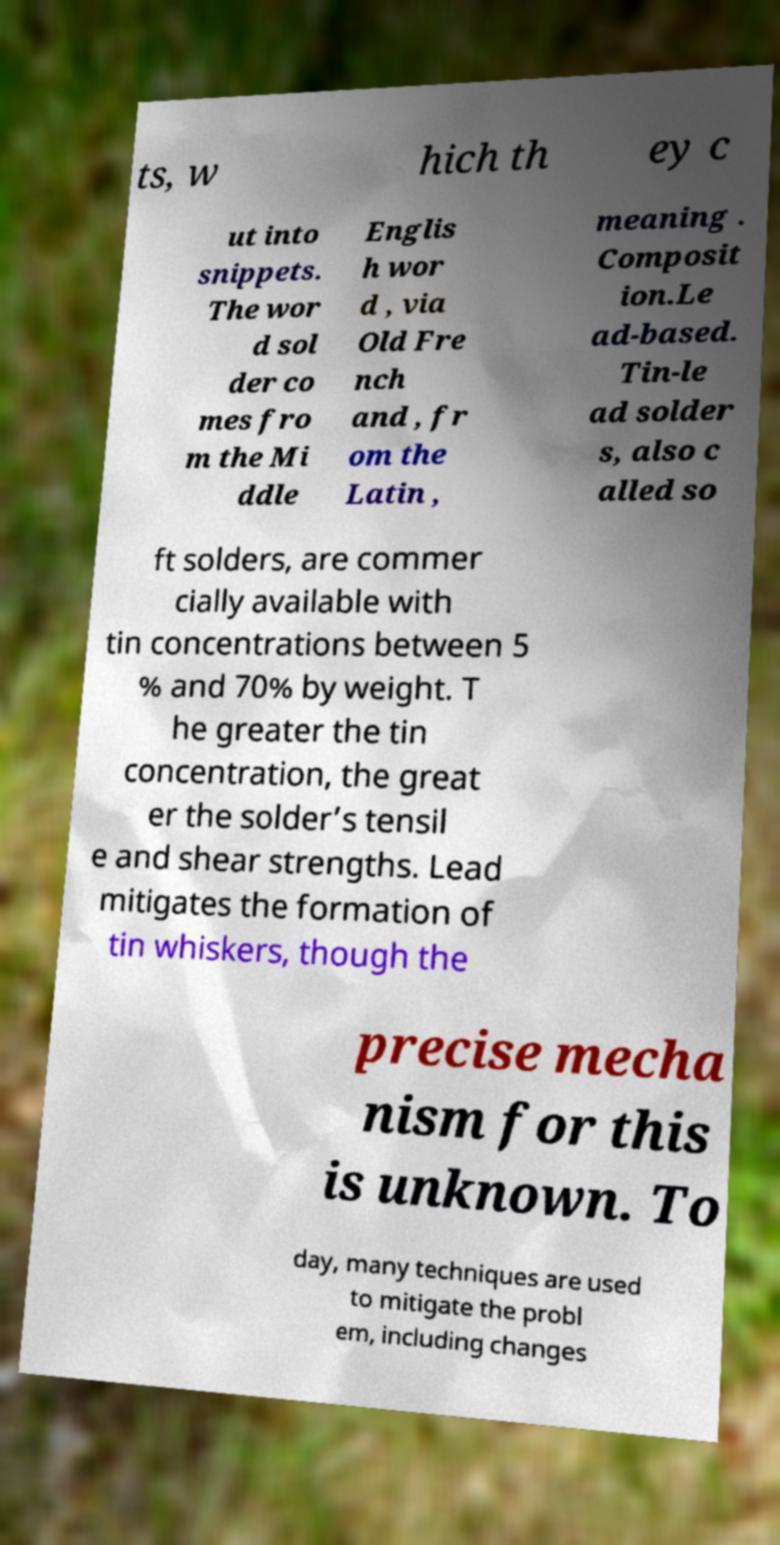For documentation purposes, I need the text within this image transcribed. Could you provide that? ts, w hich th ey c ut into snippets. The wor d sol der co mes fro m the Mi ddle Englis h wor d , via Old Fre nch and , fr om the Latin , meaning . Composit ion.Le ad-based. Tin-le ad solder s, also c alled so ft solders, are commer cially available with tin concentrations between 5 % and 70% by weight. T he greater the tin concentration, the great er the solder’s tensil e and shear strengths. Lead mitigates the formation of tin whiskers, though the precise mecha nism for this is unknown. To day, many techniques are used to mitigate the probl em, including changes 